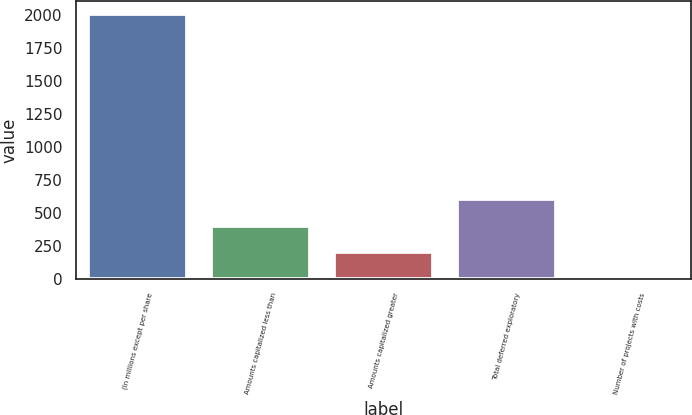Convert chart to OTSL. <chart><loc_0><loc_0><loc_500><loc_500><bar_chart><fcel>(In millions except per share<fcel>Amounts capitalized less than<fcel>Amounts capitalized greater<fcel>Total deferred exploratory<fcel>Number of projects with costs<nl><fcel>2006<fcel>403.6<fcel>203.3<fcel>603.9<fcel>3<nl></chart> 